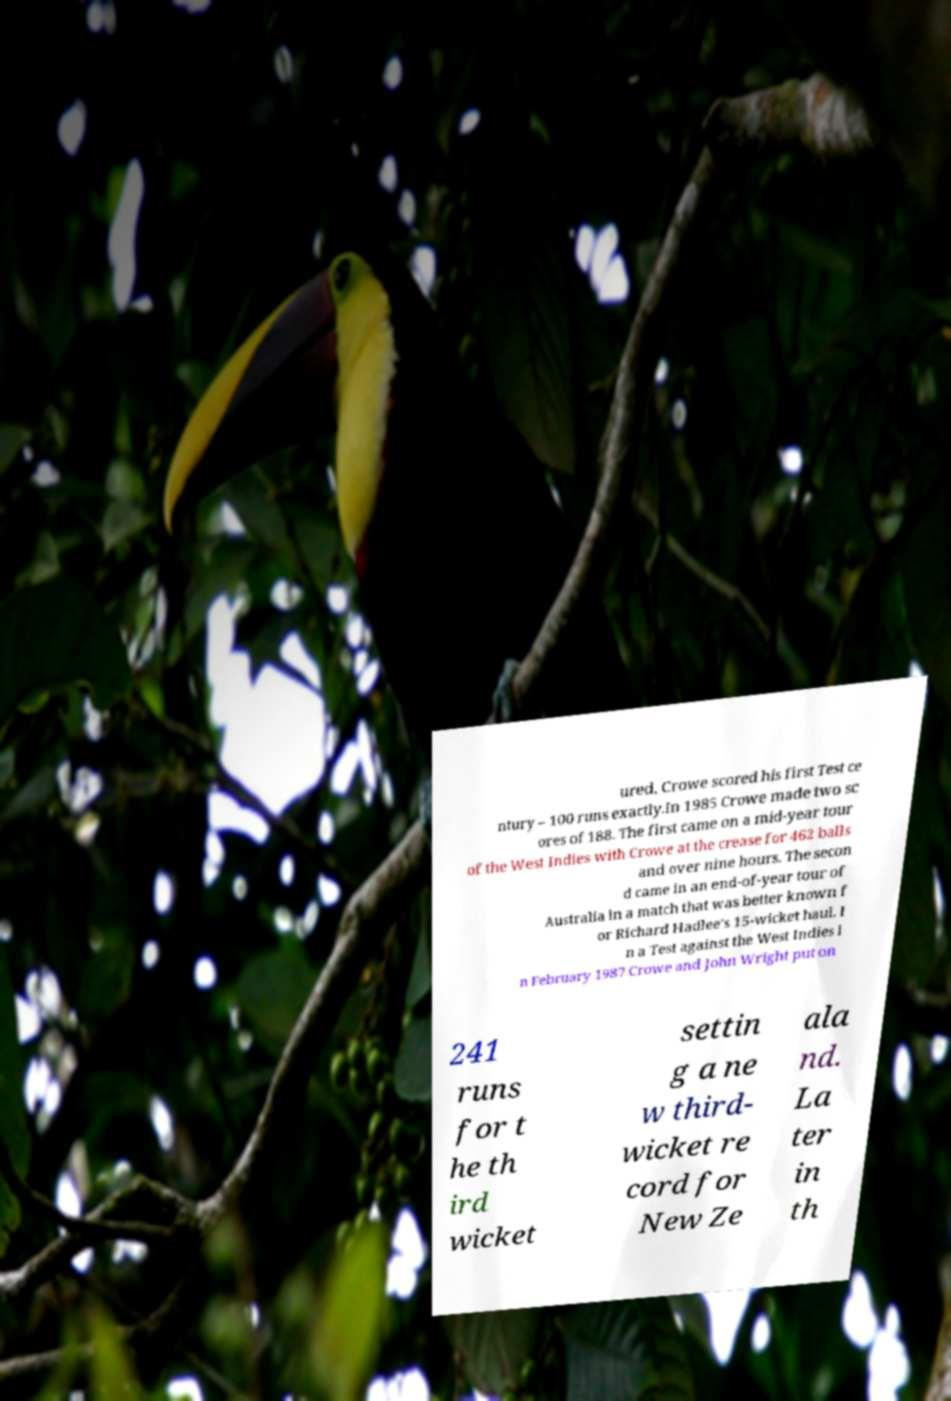What messages or text are displayed in this image? I need them in a readable, typed format. ured, Crowe scored his first Test ce ntury – 100 runs exactly.In 1985 Crowe made two sc ores of 188. The first came on a mid-year tour of the West Indies with Crowe at the crease for 462 balls and over nine hours. The secon d came in an end-of-year tour of Australia in a match that was better known f or Richard Hadlee's 15-wicket haul. I n a Test against the West Indies i n February 1987 Crowe and John Wright put on 241 runs for t he th ird wicket settin g a ne w third- wicket re cord for New Ze ala nd. La ter in th 